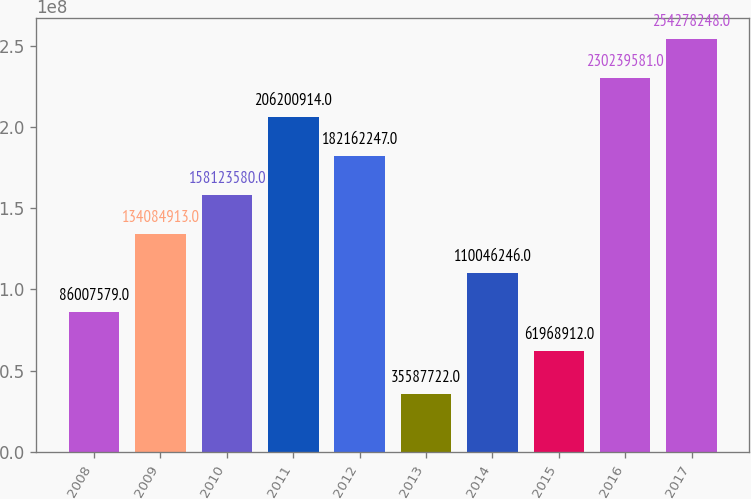Convert chart. <chart><loc_0><loc_0><loc_500><loc_500><bar_chart><fcel>2008<fcel>2009<fcel>2010<fcel>2011<fcel>2012<fcel>2013<fcel>2014<fcel>2015<fcel>2016<fcel>2017<nl><fcel>8.60076e+07<fcel>1.34085e+08<fcel>1.58124e+08<fcel>2.06201e+08<fcel>1.82162e+08<fcel>3.55877e+07<fcel>1.10046e+08<fcel>6.19689e+07<fcel>2.3024e+08<fcel>2.54278e+08<nl></chart> 